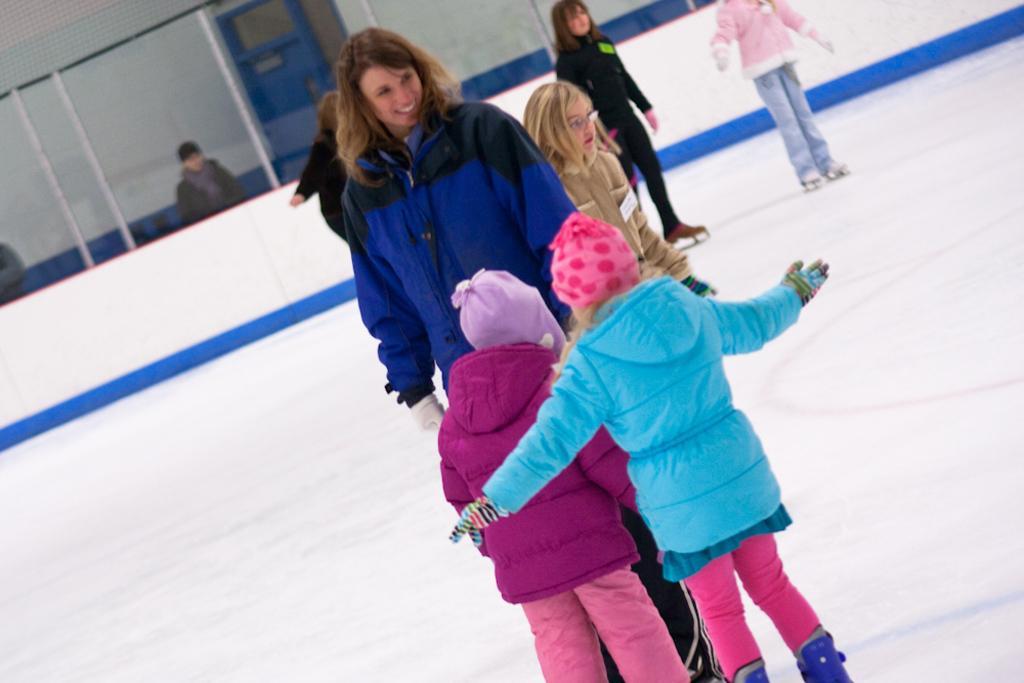Please provide a concise description of this image. In the foreground, I can see a group of people are skating on the floor. In the background, I can see a fence, two persons, door and a wall. This image taken, maybe during a day. 